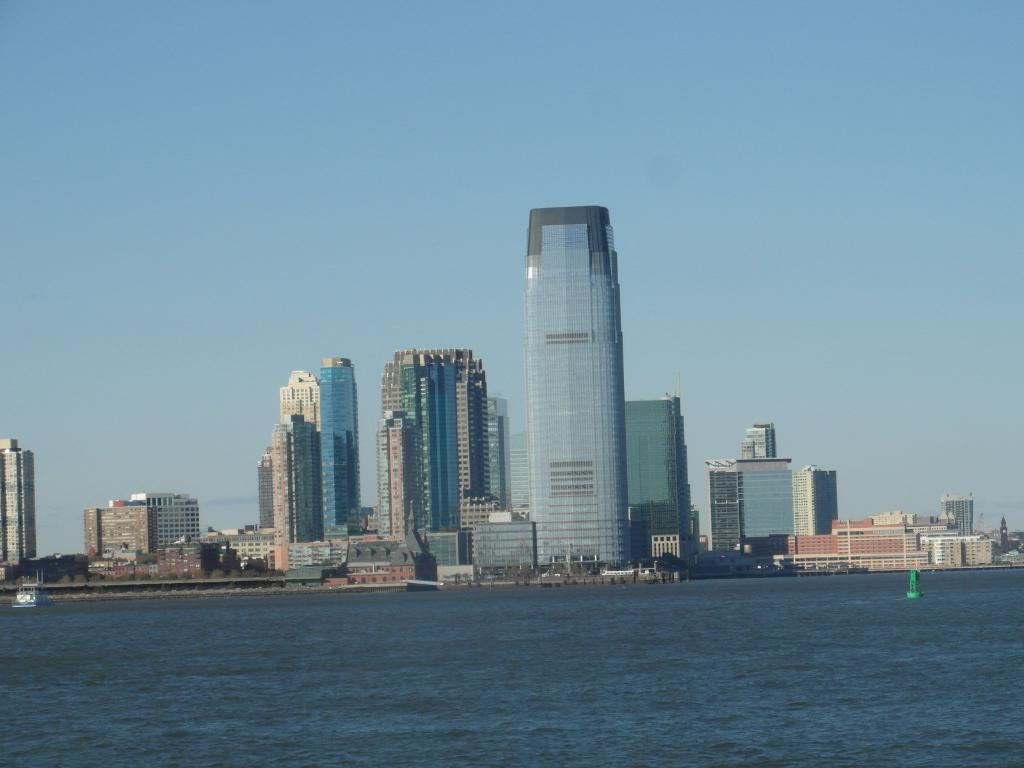What type of view is shown in the image? The image is an outside view. What can be seen at the bottom of the image? There is water visible at the bottom of the image. What is located in the middle of the image? There are many buildings and trees in the middle of the image. What is visible at the top of the image? The sky is visible at the top of the image. What is the color of the sky in the image? The color of the sky is blue. What type of basin is visible in the image? There is no basin present in the image. What season is depicted in the image? The season is not explicitly mentioned in the image, so it cannot be determined from the image alone. 